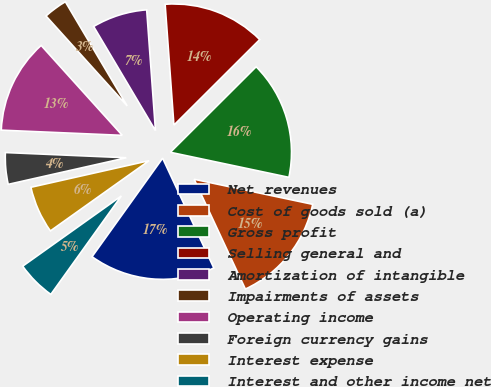Convert chart. <chart><loc_0><loc_0><loc_500><loc_500><pie_chart><fcel>Net revenues<fcel>Cost of goods sold (a)<fcel>Gross profit<fcel>Selling general and<fcel>Amortization of intangible<fcel>Impairments of assets<fcel>Operating income<fcel>Foreign currency gains<fcel>Interest expense<fcel>Interest and other income net<nl><fcel>16.84%<fcel>14.74%<fcel>15.79%<fcel>13.68%<fcel>7.37%<fcel>3.16%<fcel>12.63%<fcel>4.21%<fcel>6.32%<fcel>5.26%<nl></chart> 